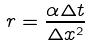Convert formula to latex. <formula><loc_0><loc_0><loc_500><loc_500>r = \frac { \alpha \Delta t } { \Delta x ^ { 2 } }</formula> 